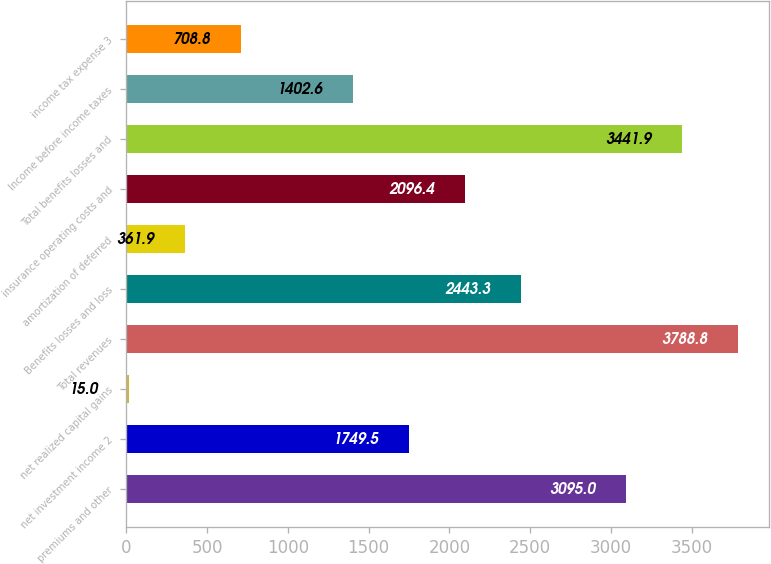Convert chart. <chart><loc_0><loc_0><loc_500><loc_500><bar_chart><fcel>premiums and other<fcel>net investment income 2<fcel>net realized capital gains<fcel>Total revenues<fcel>Benefits losses and loss<fcel>amortization of deferred<fcel>insurance operating costs and<fcel>Total benefits losses and<fcel>Income before income taxes<fcel>income tax expense 3<nl><fcel>3095<fcel>1749.5<fcel>15<fcel>3788.8<fcel>2443.3<fcel>361.9<fcel>2096.4<fcel>3441.9<fcel>1402.6<fcel>708.8<nl></chart> 